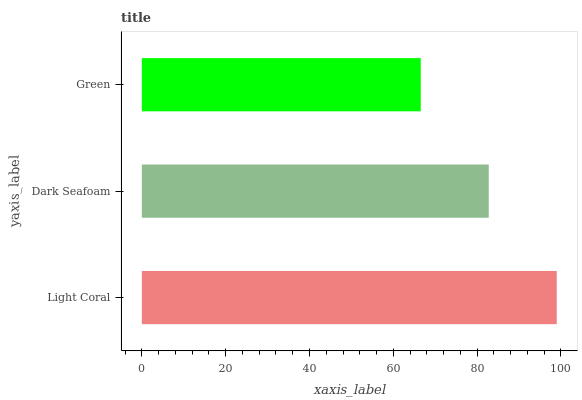Is Green the minimum?
Answer yes or no. Yes. Is Light Coral the maximum?
Answer yes or no. Yes. Is Dark Seafoam the minimum?
Answer yes or no. No. Is Dark Seafoam the maximum?
Answer yes or no. No. Is Light Coral greater than Dark Seafoam?
Answer yes or no. Yes. Is Dark Seafoam less than Light Coral?
Answer yes or no. Yes. Is Dark Seafoam greater than Light Coral?
Answer yes or no. No. Is Light Coral less than Dark Seafoam?
Answer yes or no. No. Is Dark Seafoam the high median?
Answer yes or no. Yes. Is Dark Seafoam the low median?
Answer yes or no. Yes. Is Light Coral the high median?
Answer yes or no. No. Is Green the low median?
Answer yes or no. No. 